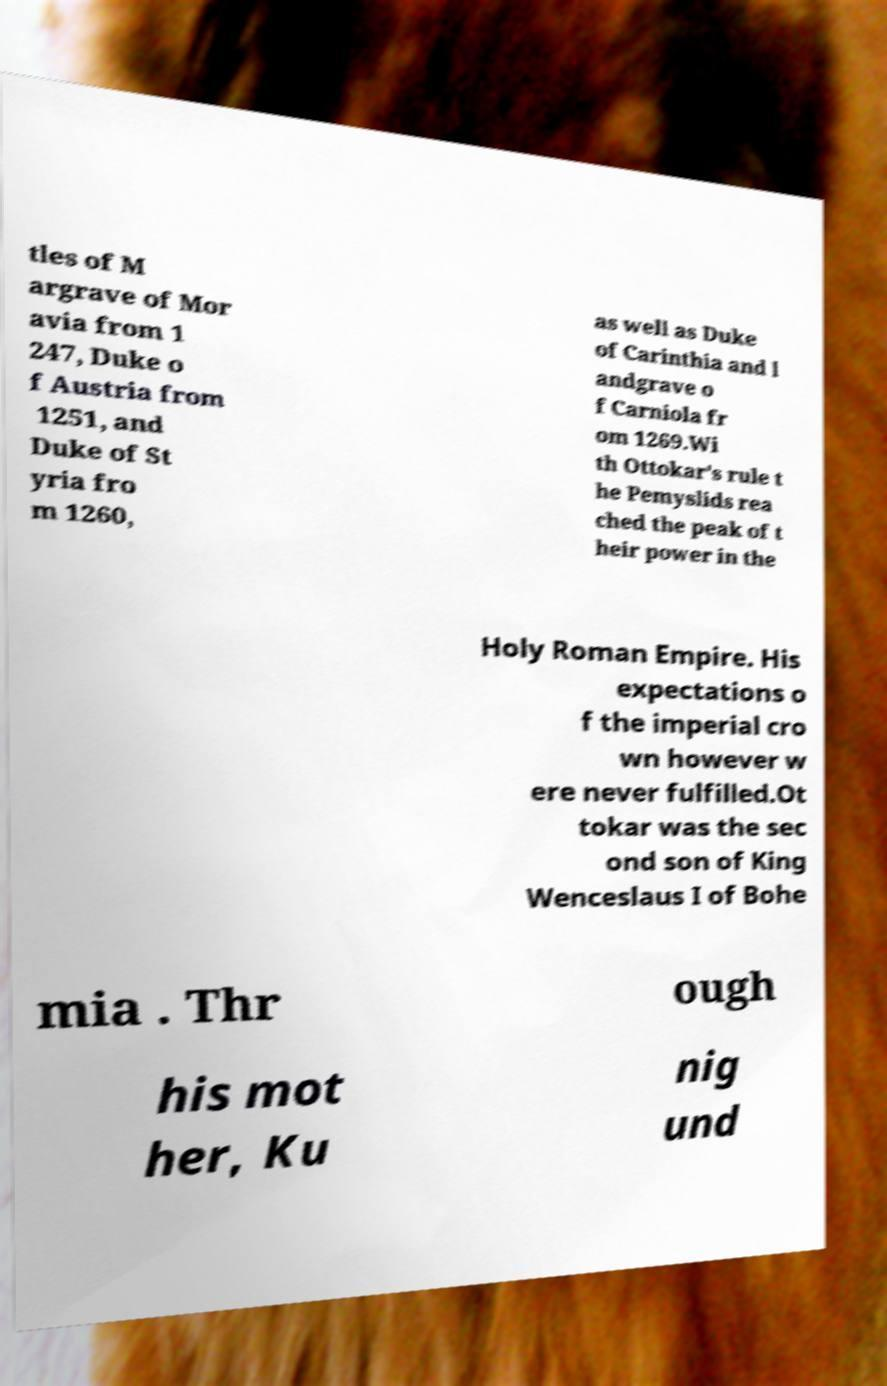For documentation purposes, I need the text within this image transcribed. Could you provide that? tles of M argrave of Mor avia from 1 247, Duke o f Austria from 1251, and Duke of St yria fro m 1260, as well as Duke of Carinthia and l andgrave o f Carniola fr om 1269.Wi th Ottokar's rule t he Pemyslids rea ched the peak of t heir power in the Holy Roman Empire. His expectations o f the imperial cro wn however w ere never fulfilled.Ot tokar was the sec ond son of King Wenceslaus I of Bohe mia . Thr ough his mot her, Ku nig und 